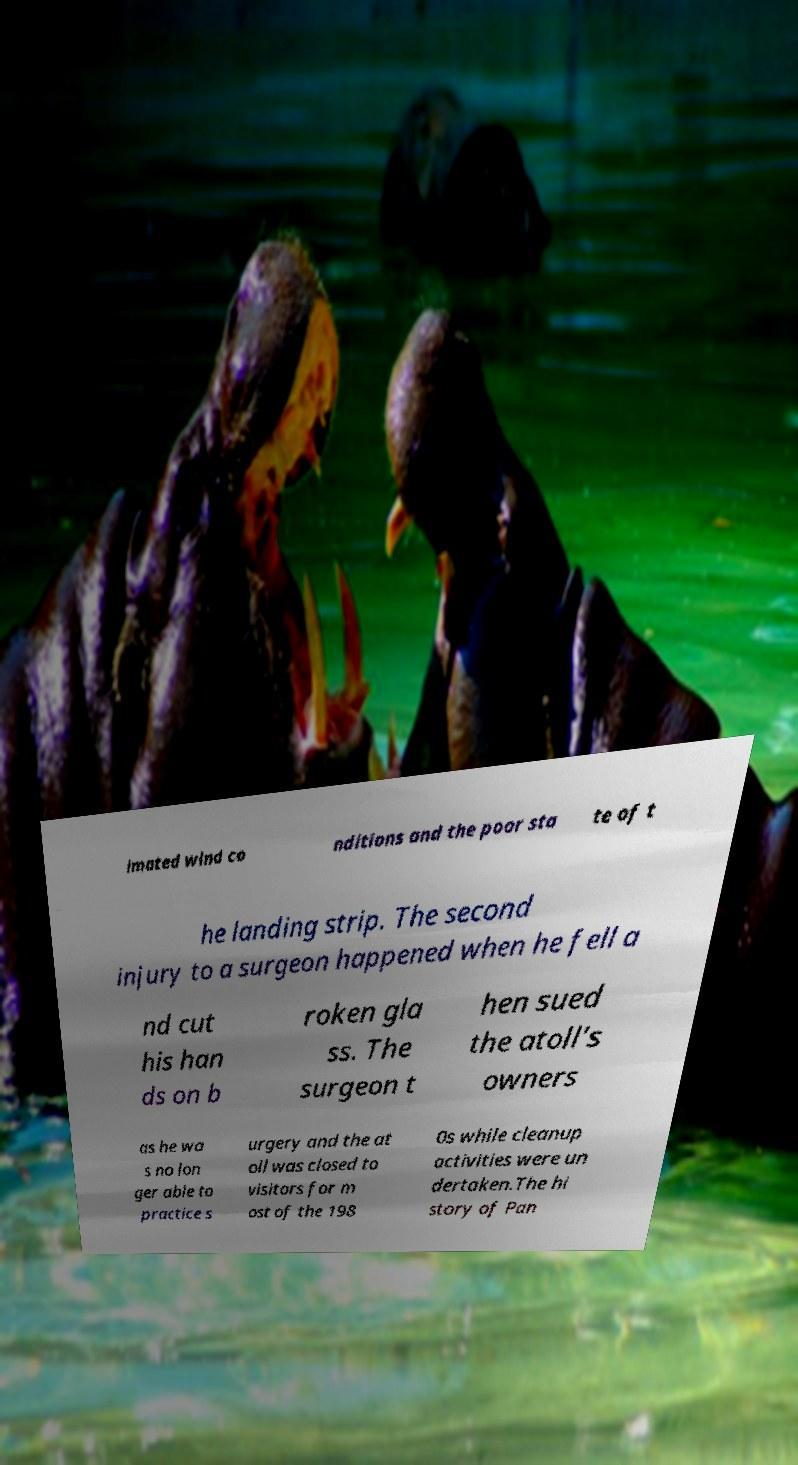Please identify and transcribe the text found in this image. imated wind co nditions and the poor sta te of t he landing strip. The second injury to a surgeon happened when he fell a nd cut his han ds on b roken gla ss. The surgeon t hen sued the atoll's owners as he wa s no lon ger able to practice s urgery and the at oll was closed to visitors for m ost of the 198 0s while cleanup activities were un dertaken.The hi story of Pan 